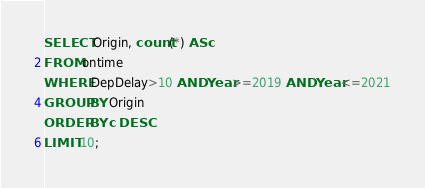<code> <loc_0><loc_0><loc_500><loc_500><_SQL_>SELECT Origin, count(*) AS c
FROM ontime
WHERE DepDelay>10 AND Year>=2019 AND Year<=2021
GROUP BY Origin
ORDER BY c DESC
LIMIT 10;</code> 